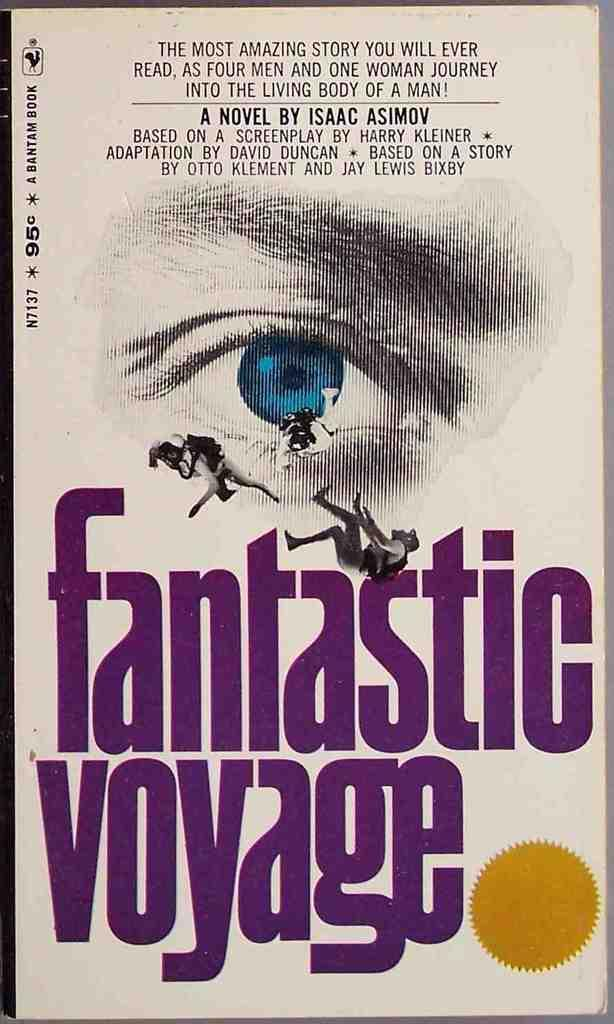<image>
Write a terse but informative summary of the picture. A book by Isaac Asimov titled Fantastic Voyage. 